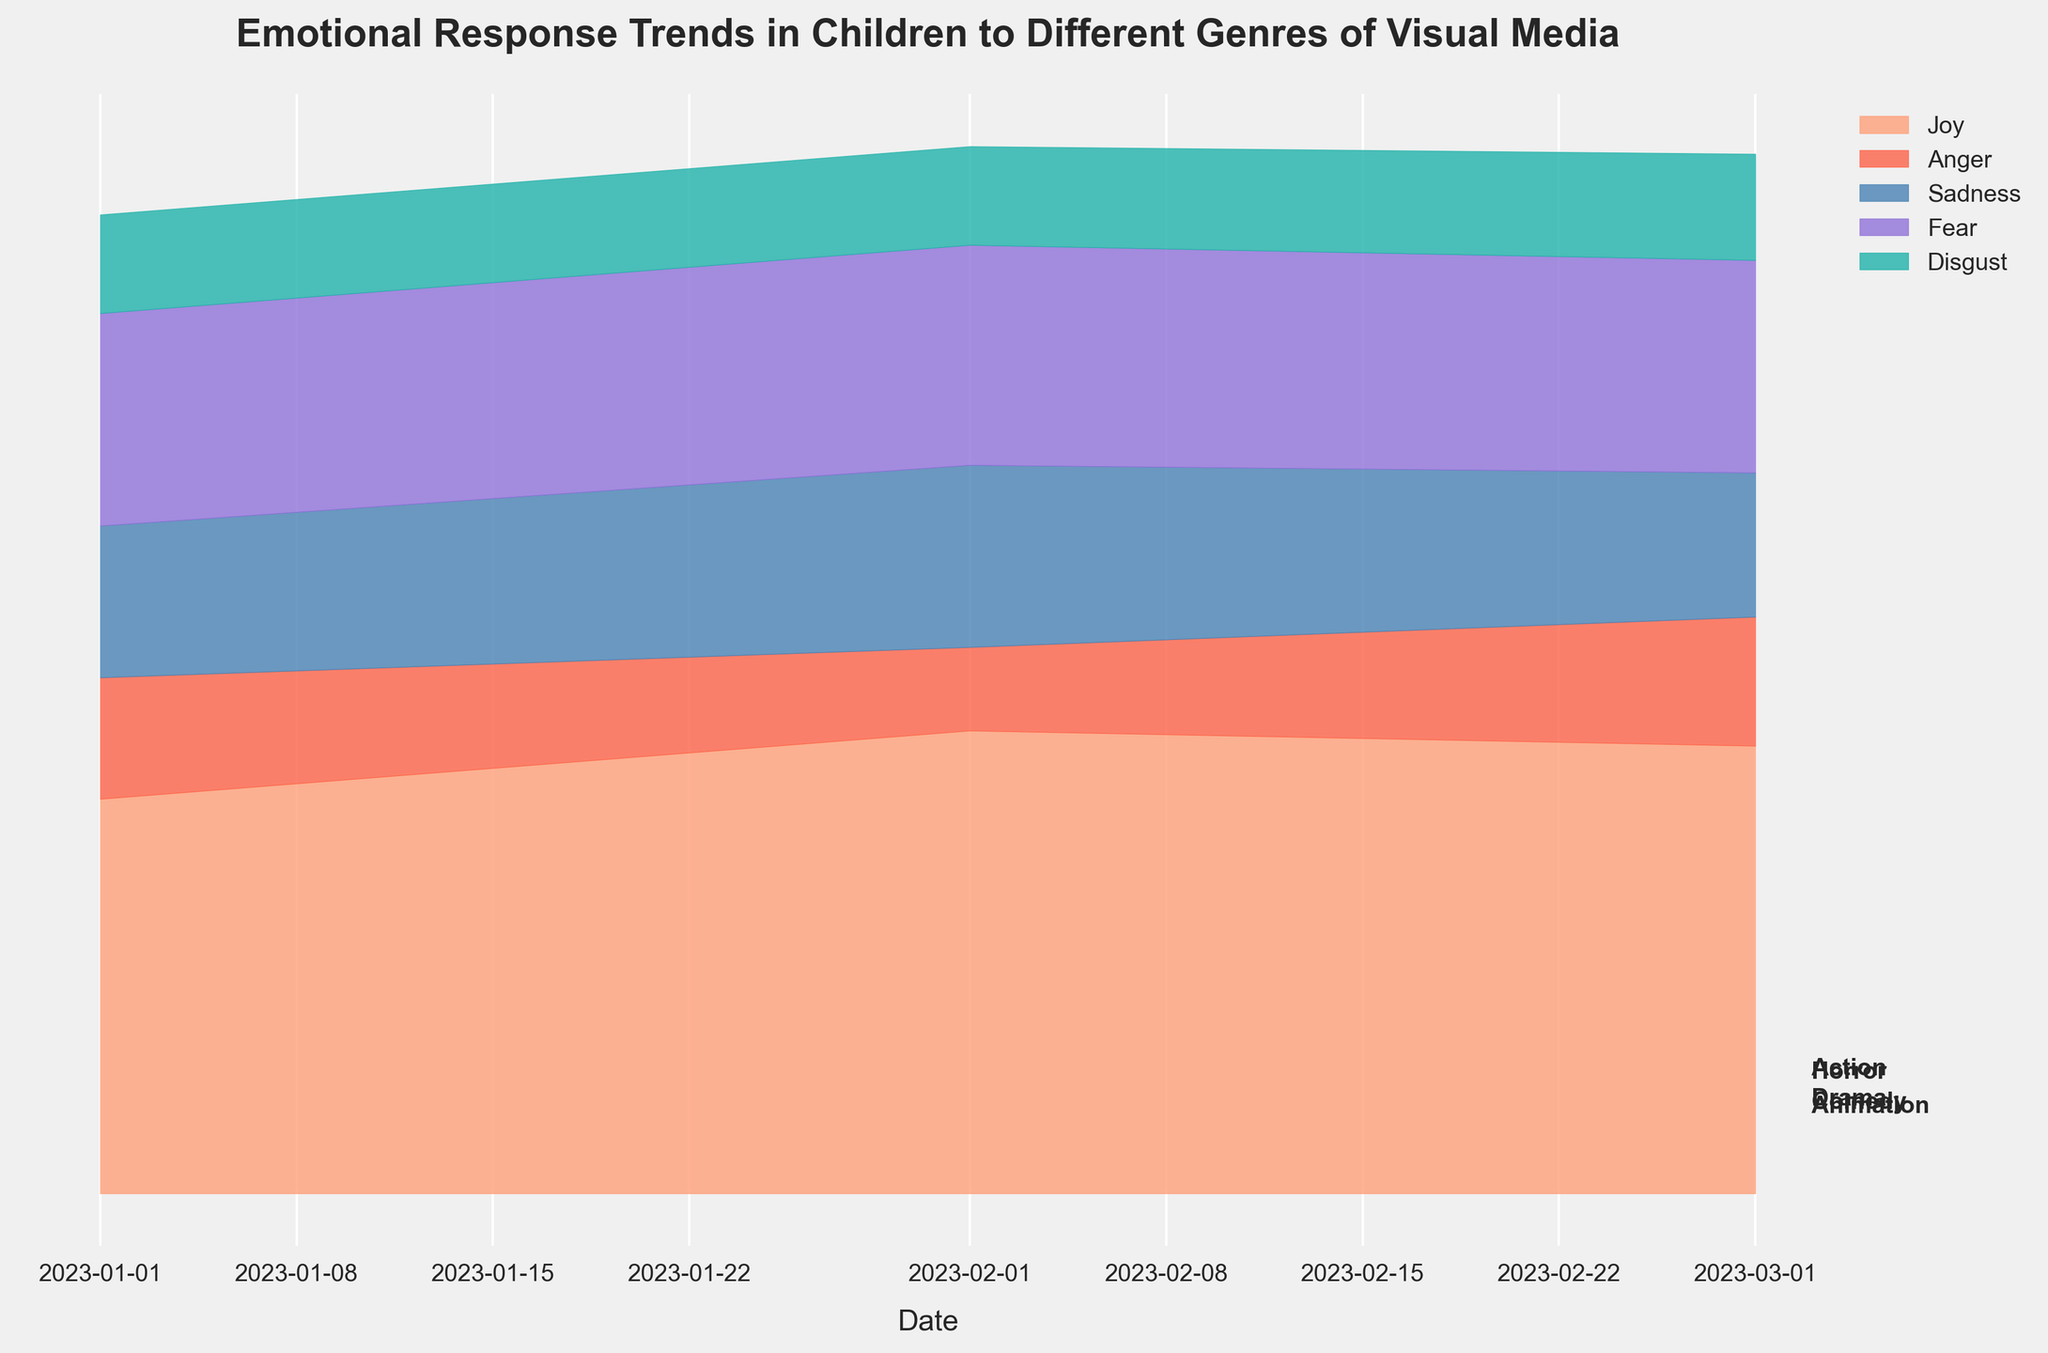What is the title of the figure? The title is typically located at the top of the figure and summarizes the contents or the main focus of the visualization. Looking at that, you can identify the title.
Answer: Emotional Response Trends in Children to Different Genres of Visual Media Which emotion has the highest value for Comedy in March 2023? To determine this, look for the Comedy section in the plot, locate the time period of March 2023, and find the emotion with the largest area under the curve.
Answer: Joy How does the trend of Fear in Horror change from January to March 2023? Focus on the Horror genre section of the plot. Compare the height of the Fear streams at the points corresponding to January, February, and March 2023 to observe any variations.
Answer: It increases Which genre has the highest overall emotional response in February 2023? Look at the figure and identify which genre has the largest total vertical span in February 2023. The height of the combined streams at this point will indicate the genre with the highest overall emotional response.
Answer: Horror What are the visible emotions represented in the figure? By looking at the legend, which labels the emotions with specific colors, you can identify the emotions shown in the figure.
Answer: Joy, Anger, Sadness, Fear, Disgust Compare the levels of Sadness in Action and Drama in January 2023. Which one is higher? Find the points in the figure representing January 2023 for both Action and Drama genres. Then compare the height of the Sadness stream in both cases.
Answer: Drama What is the general trend of Joy in Animation from January to March 2023? For the Animation genre in the plot, track the Joy stream from January to March 2023 and observe whether it is increasing, decreasing, or remaining stable.
Answer: Increasing Which genre shows the highest value of Anger in March 2023? In the figure, focus on March 2023 and look at the different genres. Identify which genre has the tallest Anger stream.
Answer: Action 